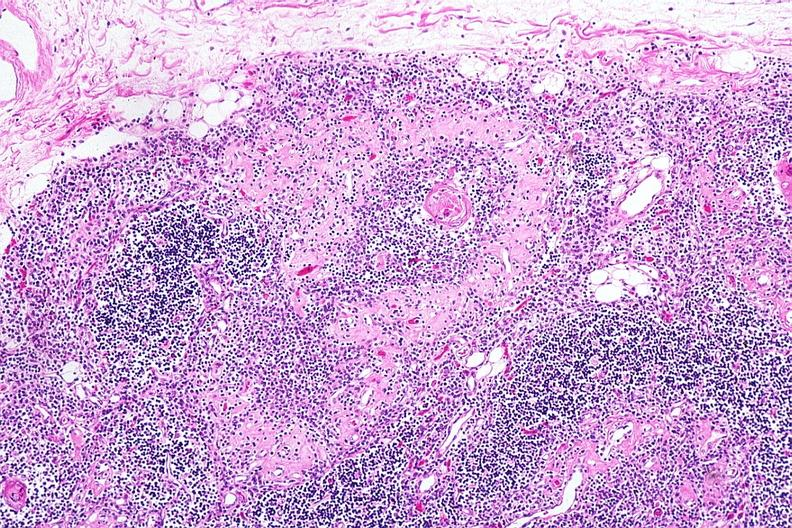what is present?
Answer the question using a single word or phrase. Hematologic 